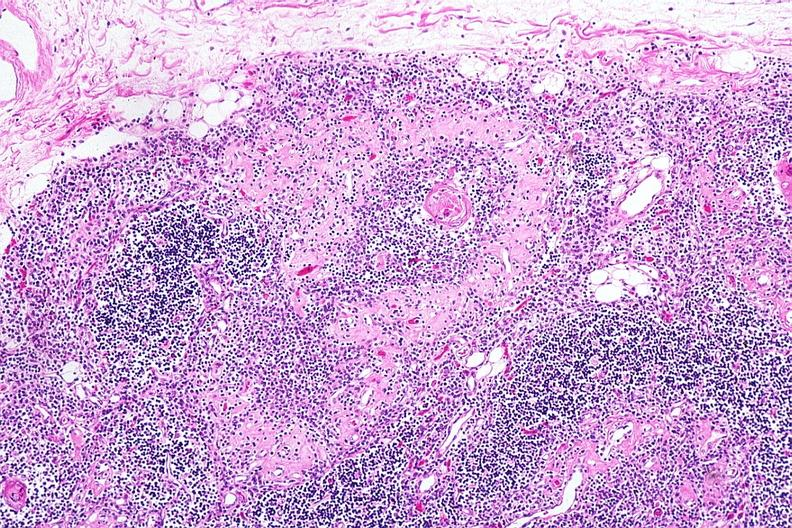what is present?
Answer the question using a single word or phrase. Hematologic 